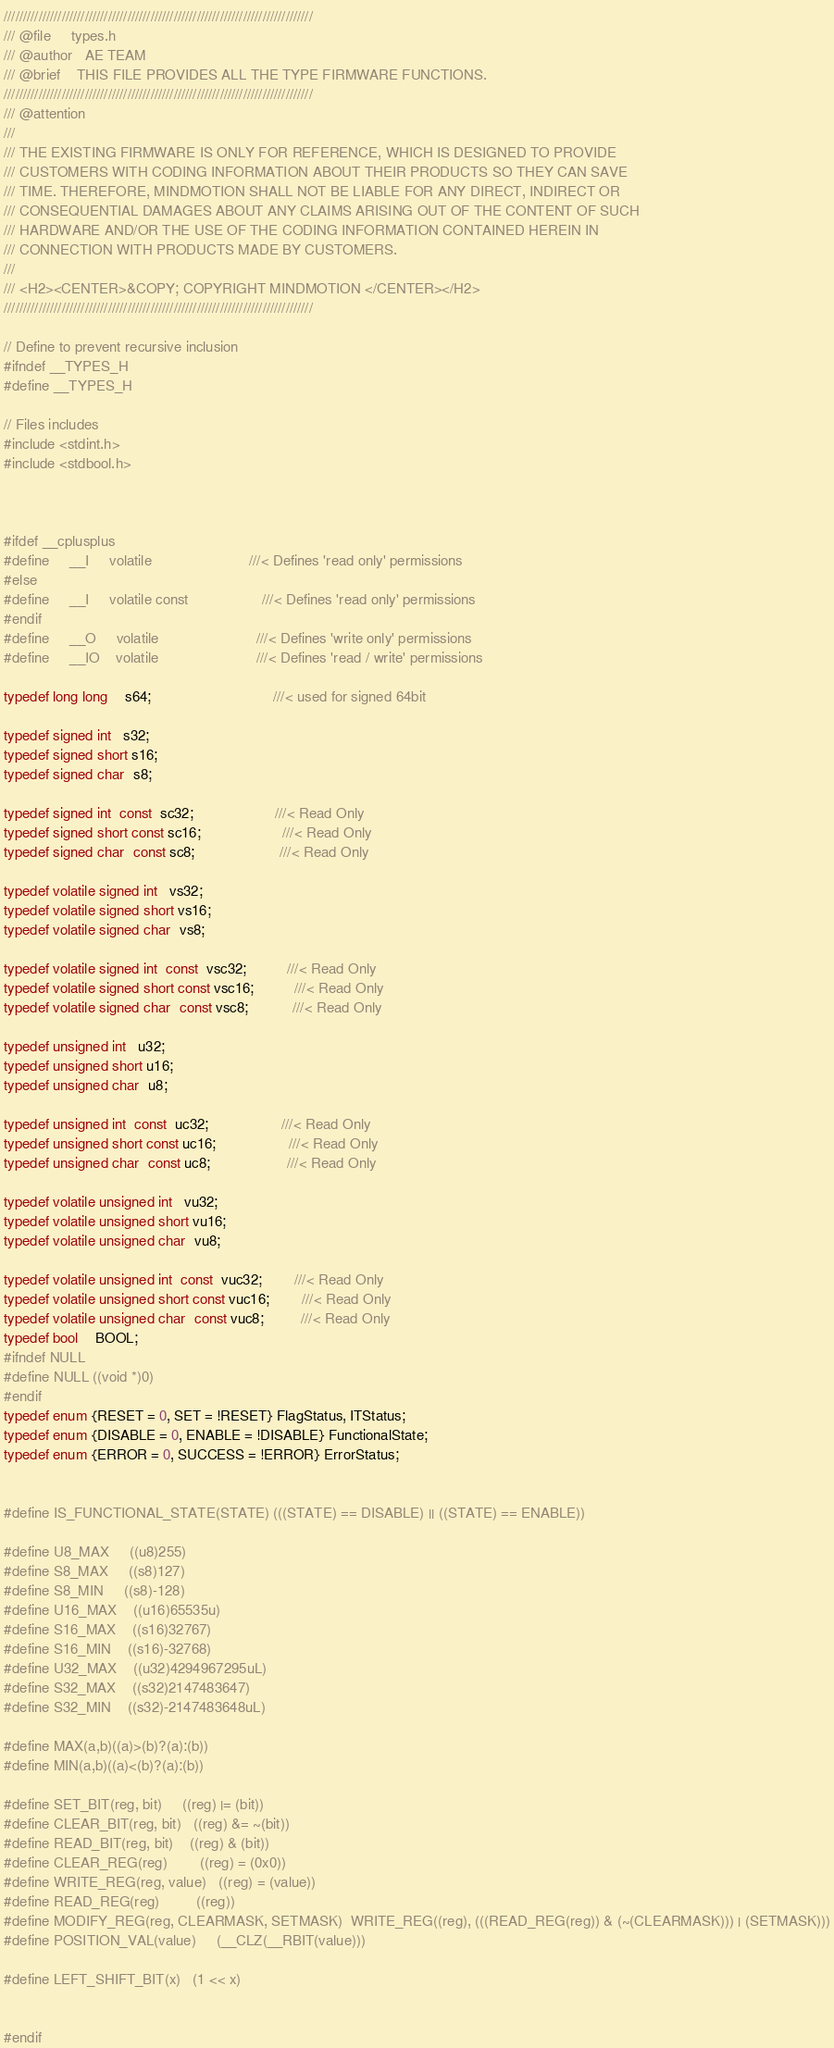<code> <loc_0><loc_0><loc_500><loc_500><_C_>////////////////////////////////////////////////////////////////////////////////
/// @file     types.h
/// @author   AE TEAM
/// @brief    THIS FILE PROVIDES ALL THE TYPE FIRMWARE FUNCTIONS.
////////////////////////////////////////////////////////////////////////////////
/// @attention
///
/// THE EXISTING FIRMWARE IS ONLY FOR REFERENCE, WHICH IS DESIGNED TO PROVIDE
/// CUSTOMERS WITH CODING INFORMATION ABOUT THEIR PRODUCTS SO THEY CAN SAVE
/// TIME. THEREFORE, MINDMOTION SHALL NOT BE LIABLE FOR ANY DIRECT, INDIRECT OR
/// CONSEQUENTIAL DAMAGES ABOUT ANY CLAIMS ARISING OUT OF THE CONTENT OF SUCH
/// HARDWARE AND/OR THE USE OF THE CODING INFORMATION CONTAINED HEREIN IN
/// CONNECTION WITH PRODUCTS MADE BY CUSTOMERS.
///
/// <H2><CENTER>&COPY; COPYRIGHT MINDMOTION </CENTER></H2>
////////////////////////////////////////////////////////////////////////////////

// Define to prevent recursive inclusion
#ifndef __TYPES_H
#define __TYPES_H

// Files includes
#include <stdint.h>
#include <stdbool.h>



#ifdef __cplusplus
#define     __I     volatile                        ///< Defines 'read only' permissions
#else
#define     __I     volatile const                  ///< Defines 'read only' permissions
#endif
#define     __O     volatile                        ///< Defines 'write only' permissions
#define     __IO    volatile                        ///< Defines 'read / write' permissions

typedef long long    s64;                              ///< used for signed 64bit

typedef signed int   s32;
typedef signed short s16;
typedef signed char  s8;

typedef signed int  const  sc32;                    ///< Read Only
typedef signed short const sc16;                    ///< Read Only
typedef signed char  const sc8;                     ///< Read Only

typedef volatile signed int   vs32;
typedef volatile signed short vs16;
typedef volatile signed char  vs8;

typedef volatile signed int  const  vsc32;          ///< Read Only
typedef volatile signed short const vsc16;          ///< Read Only
typedef volatile signed char  const vsc8;           ///< Read Only

typedef unsigned int   u32;
typedef unsigned short u16;
typedef unsigned char  u8;

typedef unsigned int  const  uc32;                  ///< Read Only
typedef unsigned short const uc16;                  ///< Read Only
typedef unsigned char  const uc8;                   ///< Read Only

typedef volatile unsigned int   vu32;
typedef volatile unsigned short vu16;
typedef volatile unsigned char  vu8;

typedef volatile unsigned int  const  vuc32;        ///< Read Only
typedef volatile unsigned short const vuc16;        ///< Read Only
typedef volatile unsigned char  const vuc8;         ///< Read Only
typedef bool    BOOL;
#ifndef NULL
#define NULL ((void *)0)
#endif
typedef enum {RESET = 0, SET = !RESET} FlagStatus, ITStatus;
typedef enum {DISABLE = 0, ENABLE = !DISABLE} FunctionalState;
typedef enum {ERROR = 0, SUCCESS = !ERROR} ErrorStatus;


#define IS_FUNCTIONAL_STATE(STATE) (((STATE) == DISABLE) || ((STATE) == ENABLE))

#define U8_MAX     ((u8)255)
#define S8_MAX     ((s8)127)
#define S8_MIN     ((s8)-128)
#define U16_MAX    ((u16)65535u)
#define S16_MAX    ((s16)32767)
#define S16_MIN    ((s16)-32768)
#define U32_MAX    ((u32)4294967295uL)
#define S32_MAX    ((s32)2147483647)
#define S32_MIN    ((s32)-2147483648uL)

#define MAX(a,b)((a)>(b)?(a):(b))
#define MIN(a,b)((a)<(b)?(a):(b))

#define SET_BIT(reg, bit)     ((reg) |= (bit))
#define CLEAR_BIT(reg, bit)   ((reg) &= ~(bit))
#define READ_BIT(reg, bit)    ((reg) & (bit))
#define CLEAR_REG(reg)        ((reg) = (0x0))
#define WRITE_REG(reg, value)   ((reg) = (value))
#define READ_REG(reg)         ((reg))
#define MODIFY_REG(reg, CLEARMASK, SETMASK)  WRITE_REG((reg), (((READ_REG(reg)) & (~(CLEARMASK))) | (SETMASK)))
#define POSITION_VAL(value)     (__CLZ(__RBIT(value)))

#define LEFT_SHIFT_BIT(x)   (1 << x)


#endif
</code> 